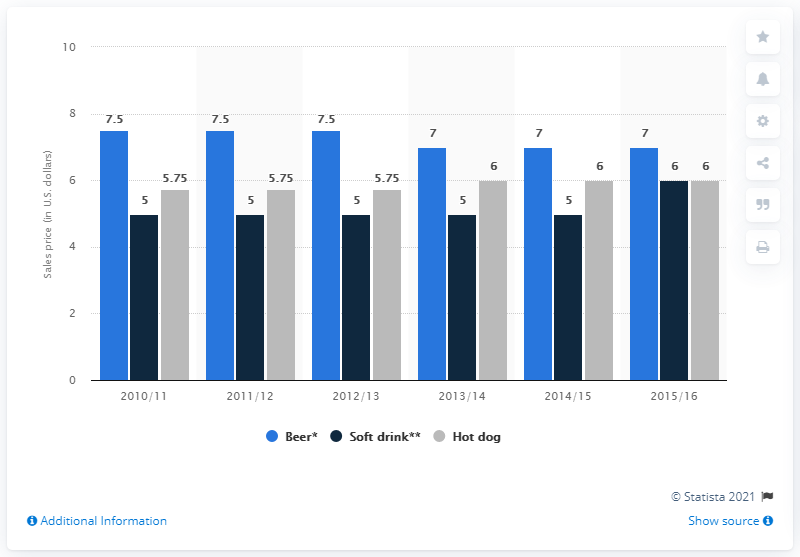Point out several critical features in this image. The addition of the prices between beer and soft drink is 12.5. Beer was the beverage that had the highest price among the three options offered, 